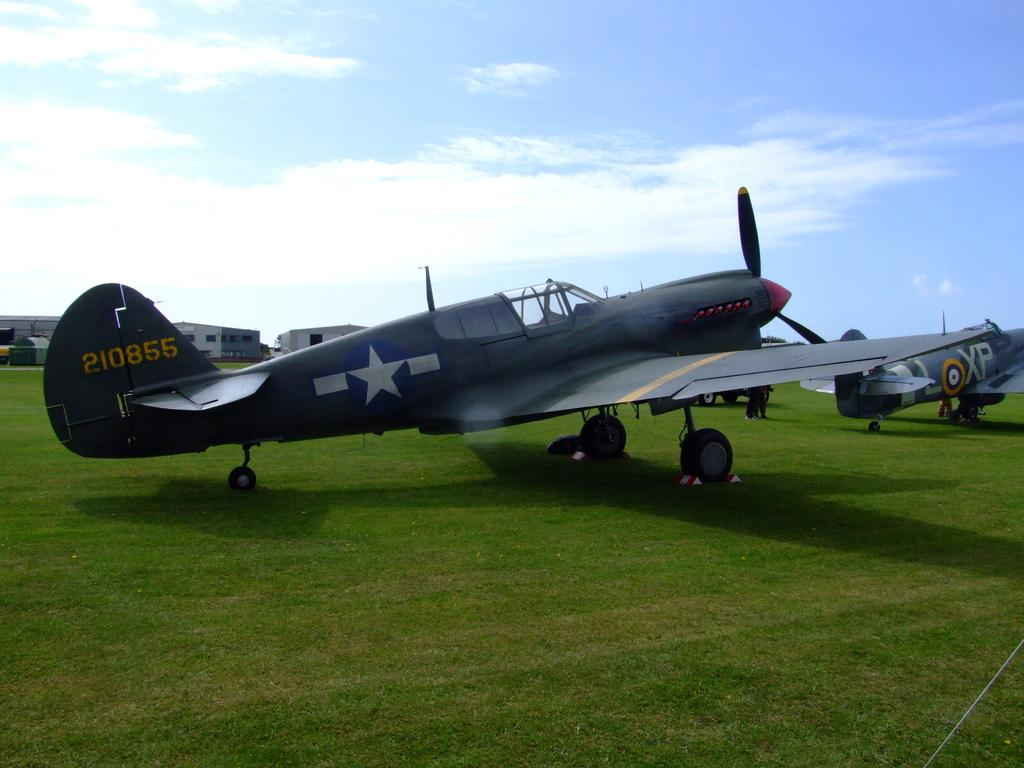<image>
Write a terse but informative summary of the picture. the numbers 855 are on the side of a plane 